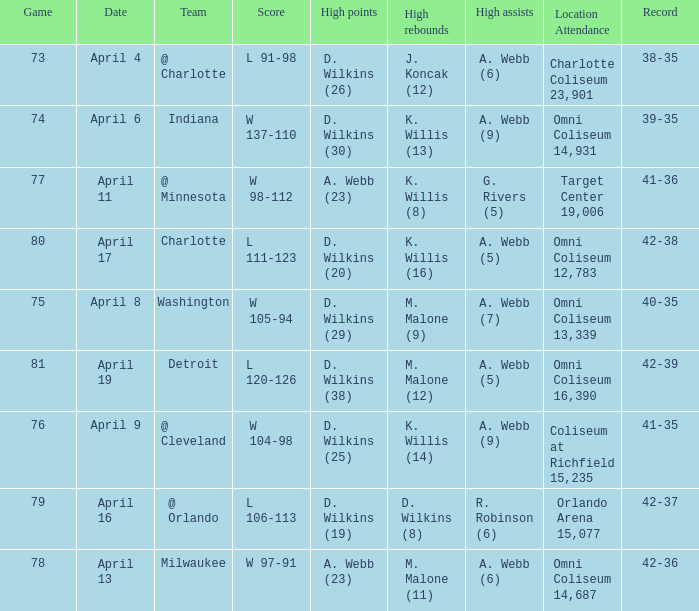Where was the location and attendance when they played milwaukee? Omni Coliseum 14,687. Would you mind parsing the complete table? {'header': ['Game', 'Date', 'Team', 'Score', 'High points', 'High rebounds', 'High assists', 'Location Attendance', 'Record'], 'rows': [['73', 'April 4', '@ Charlotte', 'L 91-98', 'D. Wilkins (26)', 'J. Koncak (12)', 'A. Webb (6)', 'Charlotte Coliseum 23,901', '38-35'], ['74', 'April 6', 'Indiana', 'W 137-110', 'D. Wilkins (30)', 'K. Willis (13)', 'A. Webb (9)', 'Omni Coliseum 14,931', '39-35'], ['77', 'April 11', '@ Minnesota', 'W 98-112', 'A. Webb (23)', 'K. Willis (8)', 'G. Rivers (5)', 'Target Center 19,006', '41-36'], ['80', 'April 17', 'Charlotte', 'L 111-123', 'D. Wilkins (20)', 'K. Willis (16)', 'A. Webb (5)', 'Omni Coliseum 12,783', '42-38'], ['75', 'April 8', 'Washington', 'W 105-94', 'D. Wilkins (29)', 'M. Malone (9)', 'A. Webb (7)', 'Omni Coliseum 13,339', '40-35'], ['81', 'April 19', 'Detroit', 'L 120-126', 'D. Wilkins (38)', 'M. Malone (12)', 'A. Webb (5)', 'Omni Coliseum 16,390', '42-39'], ['76', 'April 9', '@ Cleveland', 'W 104-98', 'D. Wilkins (25)', 'K. Willis (14)', 'A. Webb (9)', 'Coliseum at Richfield 15,235', '41-35'], ['79', 'April 16', '@ Orlando', 'L 106-113', 'D. Wilkins (19)', 'D. Wilkins (8)', 'R. Robinson (6)', 'Orlando Arena 15,077', '42-37'], ['78', 'April 13', 'Milwaukee', 'W 97-91', 'A. Webb (23)', 'M. Malone (11)', 'A. Webb (6)', 'Omni Coliseum 14,687', '42-36']]} 